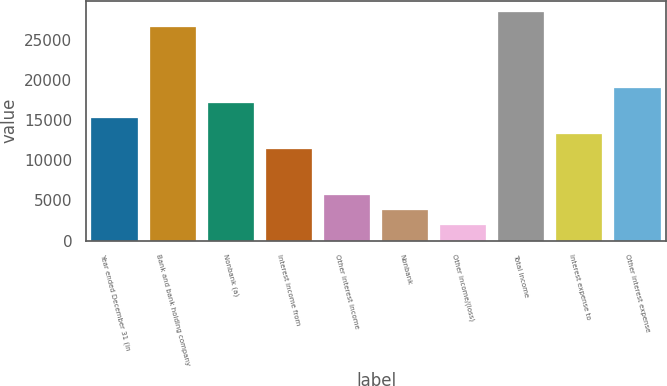Convert chart. <chart><loc_0><loc_0><loc_500><loc_500><bar_chart><fcel>Year ended December 31 (in<fcel>Bank and bank holding company<fcel>Nonbank (a)<fcel>Interest income from<fcel>Other interest income<fcel>Nonbank<fcel>Other income/(loss)<fcel>Total income<fcel>Interest expense to<fcel>Other interest expense<nl><fcel>15192.2<fcel>26543.6<fcel>17084.1<fcel>11408.4<fcel>5732.7<fcel>3840.8<fcel>1948.9<fcel>28435.5<fcel>13300.3<fcel>18976<nl></chart> 